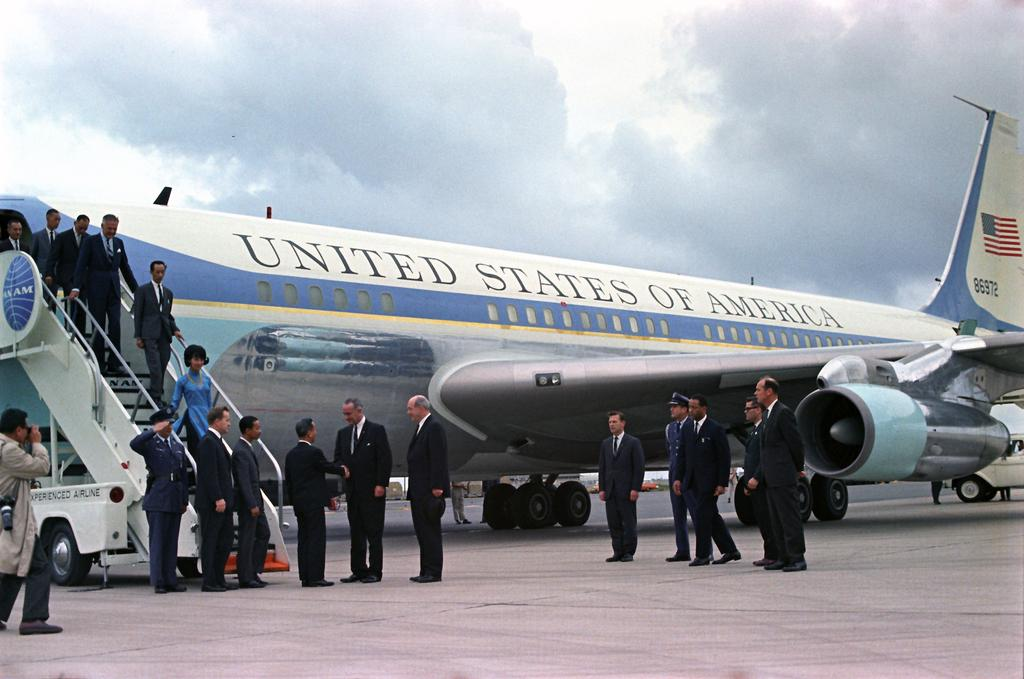<image>
Relay a brief, clear account of the picture shown. People exiting an aeroplane with the words United States of America on it 